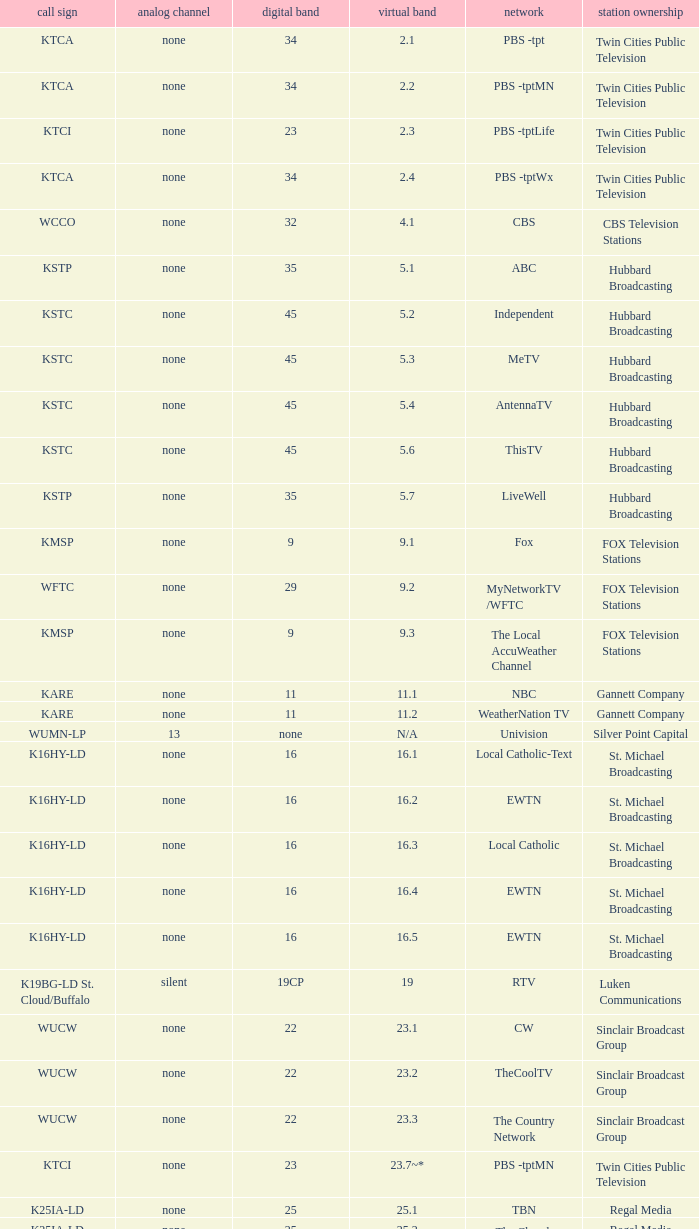Which virtual network is associated with station ownership of eicb tv and a call sign of ktcj-ld? 50.1. 